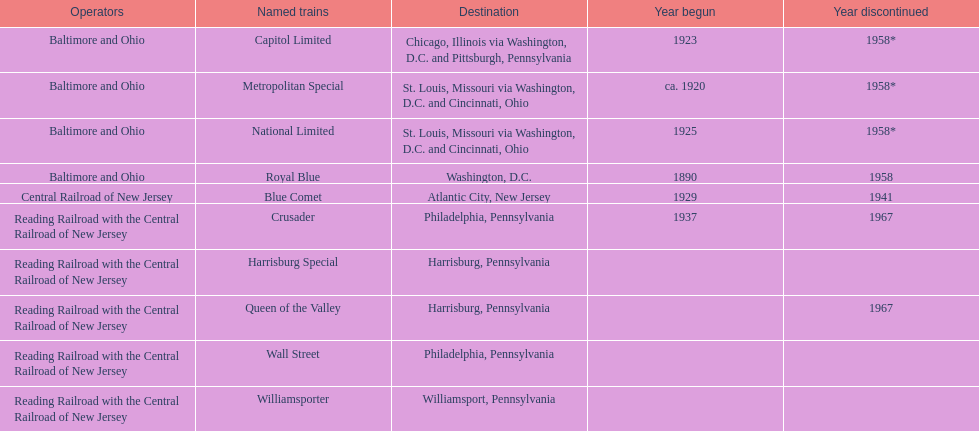Apart from the wall street train, which other train was headed to philadelphia? Crusader. 